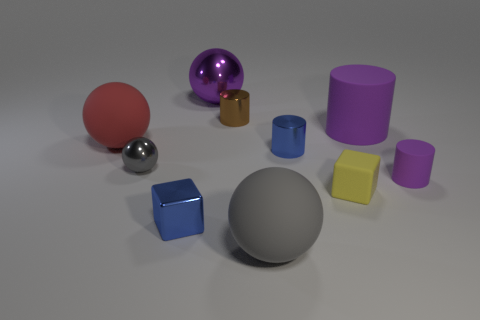What number of other things are there of the same shape as the large gray object?
Offer a terse response. 3. Is the material of the large thing in front of the red rubber object the same as the small gray object?
Make the answer very short. No. Are there the same number of brown shiny cylinders that are behind the brown cylinder and blue shiny objects that are to the right of the small yellow cube?
Give a very brief answer. Yes. How big is the blue object that is behind the tiny matte cylinder?
Make the answer very short. Small. Is there a large gray sphere that has the same material as the brown cylinder?
Your answer should be very brief. No. Does the rubber cylinder behind the red object have the same color as the small matte block?
Offer a terse response. No. Are there an equal number of tiny cubes that are to the left of the yellow block and yellow matte cubes?
Offer a terse response. Yes. Are there any small objects of the same color as the large metal object?
Give a very brief answer. Yes. Do the brown metallic cylinder and the purple metal object have the same size?
Offer a terse response. No. There is a matte sphere that is to the right of the big matte ball behind the gray metallic sphere; what is its size?
Make the answer very short. Large. 